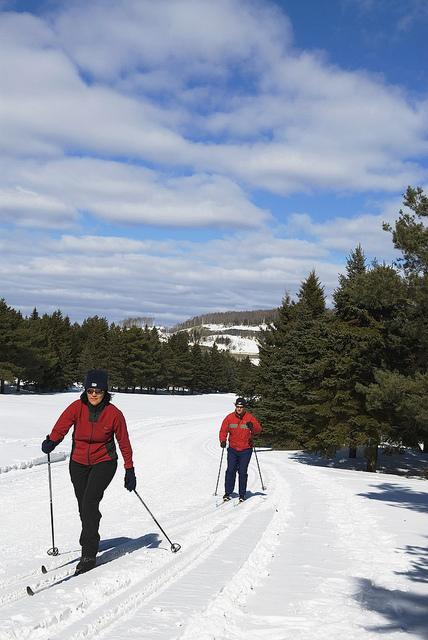What action are the people taking? Please explain your reasoning. ascend. They are gaining elevation as they go up the hill 